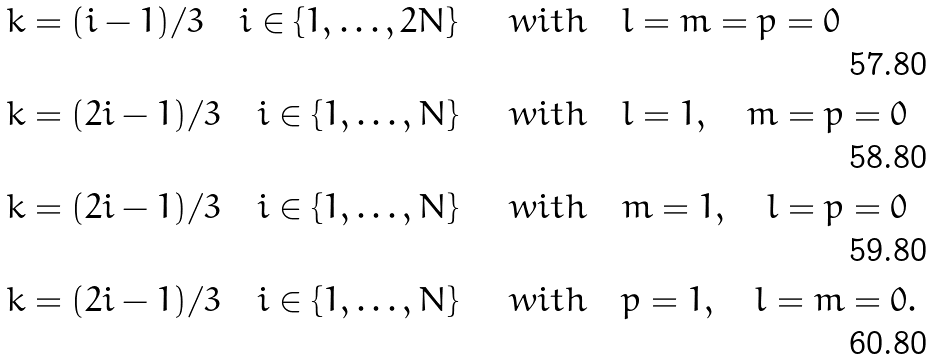<formula> <loc_0><loc_0><loc_500><loc_500>& k = ( i - 1 ) / 3 \quad i \in \{ 1 , \dots , 2 N \} \quad & w i t h \quad & l = m = p = 0 \\ & k = ( 2 i - 1 ) / 3 \quad i \in \{ 1 , \dots , N \} \quad & w i t h \quad & l = 1 , \quad m = p = 0 \\ & k = ( 2 i - 1 ) / 3 \quad i \in \{ 1 , \dots , N \} \quad & w i t h \quad & m = 1 , \quad l = p = 0 \\ & k = ( 2 i - 1 ) / 3 \quad i \in \{ 1 , \dots , N \} \quad & w i t h \quad & p = 1 , \quad l = m = 0 .</formula> 